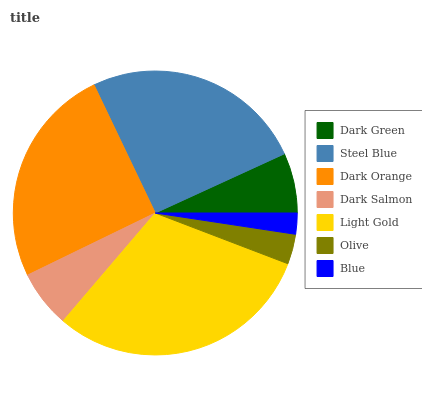Is Blue the minimum?
Answer yes or no. Yes. Is Light Gold the maximum?
Answer yes or no. Yes. Is Steel Blue the minimum?
Answer yes or no. No. Is Steel Blue the maximum?
Answer yes or no. No. Is Steel Blue greater than Dark Green?
Answer yes or no. Yes. Is Dark Green less than Steel Blue?
Answer yes or no. Yes. Is Dark Green greater than Steel Blue?
Answer yes or no. No. Is Steel Blue less than Dark Green?
Answer yes or no. No. Is Dark Green the high median?
Answer yes or no. Yes. Is Dark Green the low median?
Answer yes or no. Yes. Is Steel Blue the high median?
Answer yes or no. No. Is Dark Orange the low median?
Answer yes or no. No. 